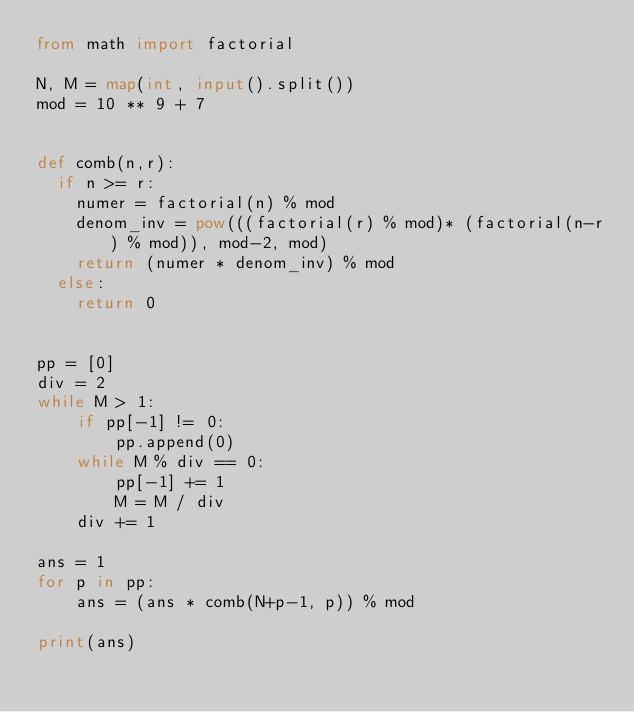Convert code to text. <code><loc_0><loc_0><loc_500><loc_500><_Python_>from math import factorial

N, M = map(int, input().split())
mod = 10 ** 9 + 7


def comb(n,r):
  if n >= r:
    numer = factorial(n) % mod
    denom_inv = pow(((factorial(r) % mod)* (factorial(n-r) % mod)), mod-2, mod)
    return (numer * denom_inv) % mod
  else:
    return 0


pp = [0]
div = 2
while M > 1:
    if pp[-1] != 0:
        pp.append(0)
    while M % div == 0:
        pp[-1] += 1
        M = M / div
    div += 1

ans = 1
for p in pp:
    ans = (ans * comb(N+p-1, p)) % mod

print(ans)</code> 